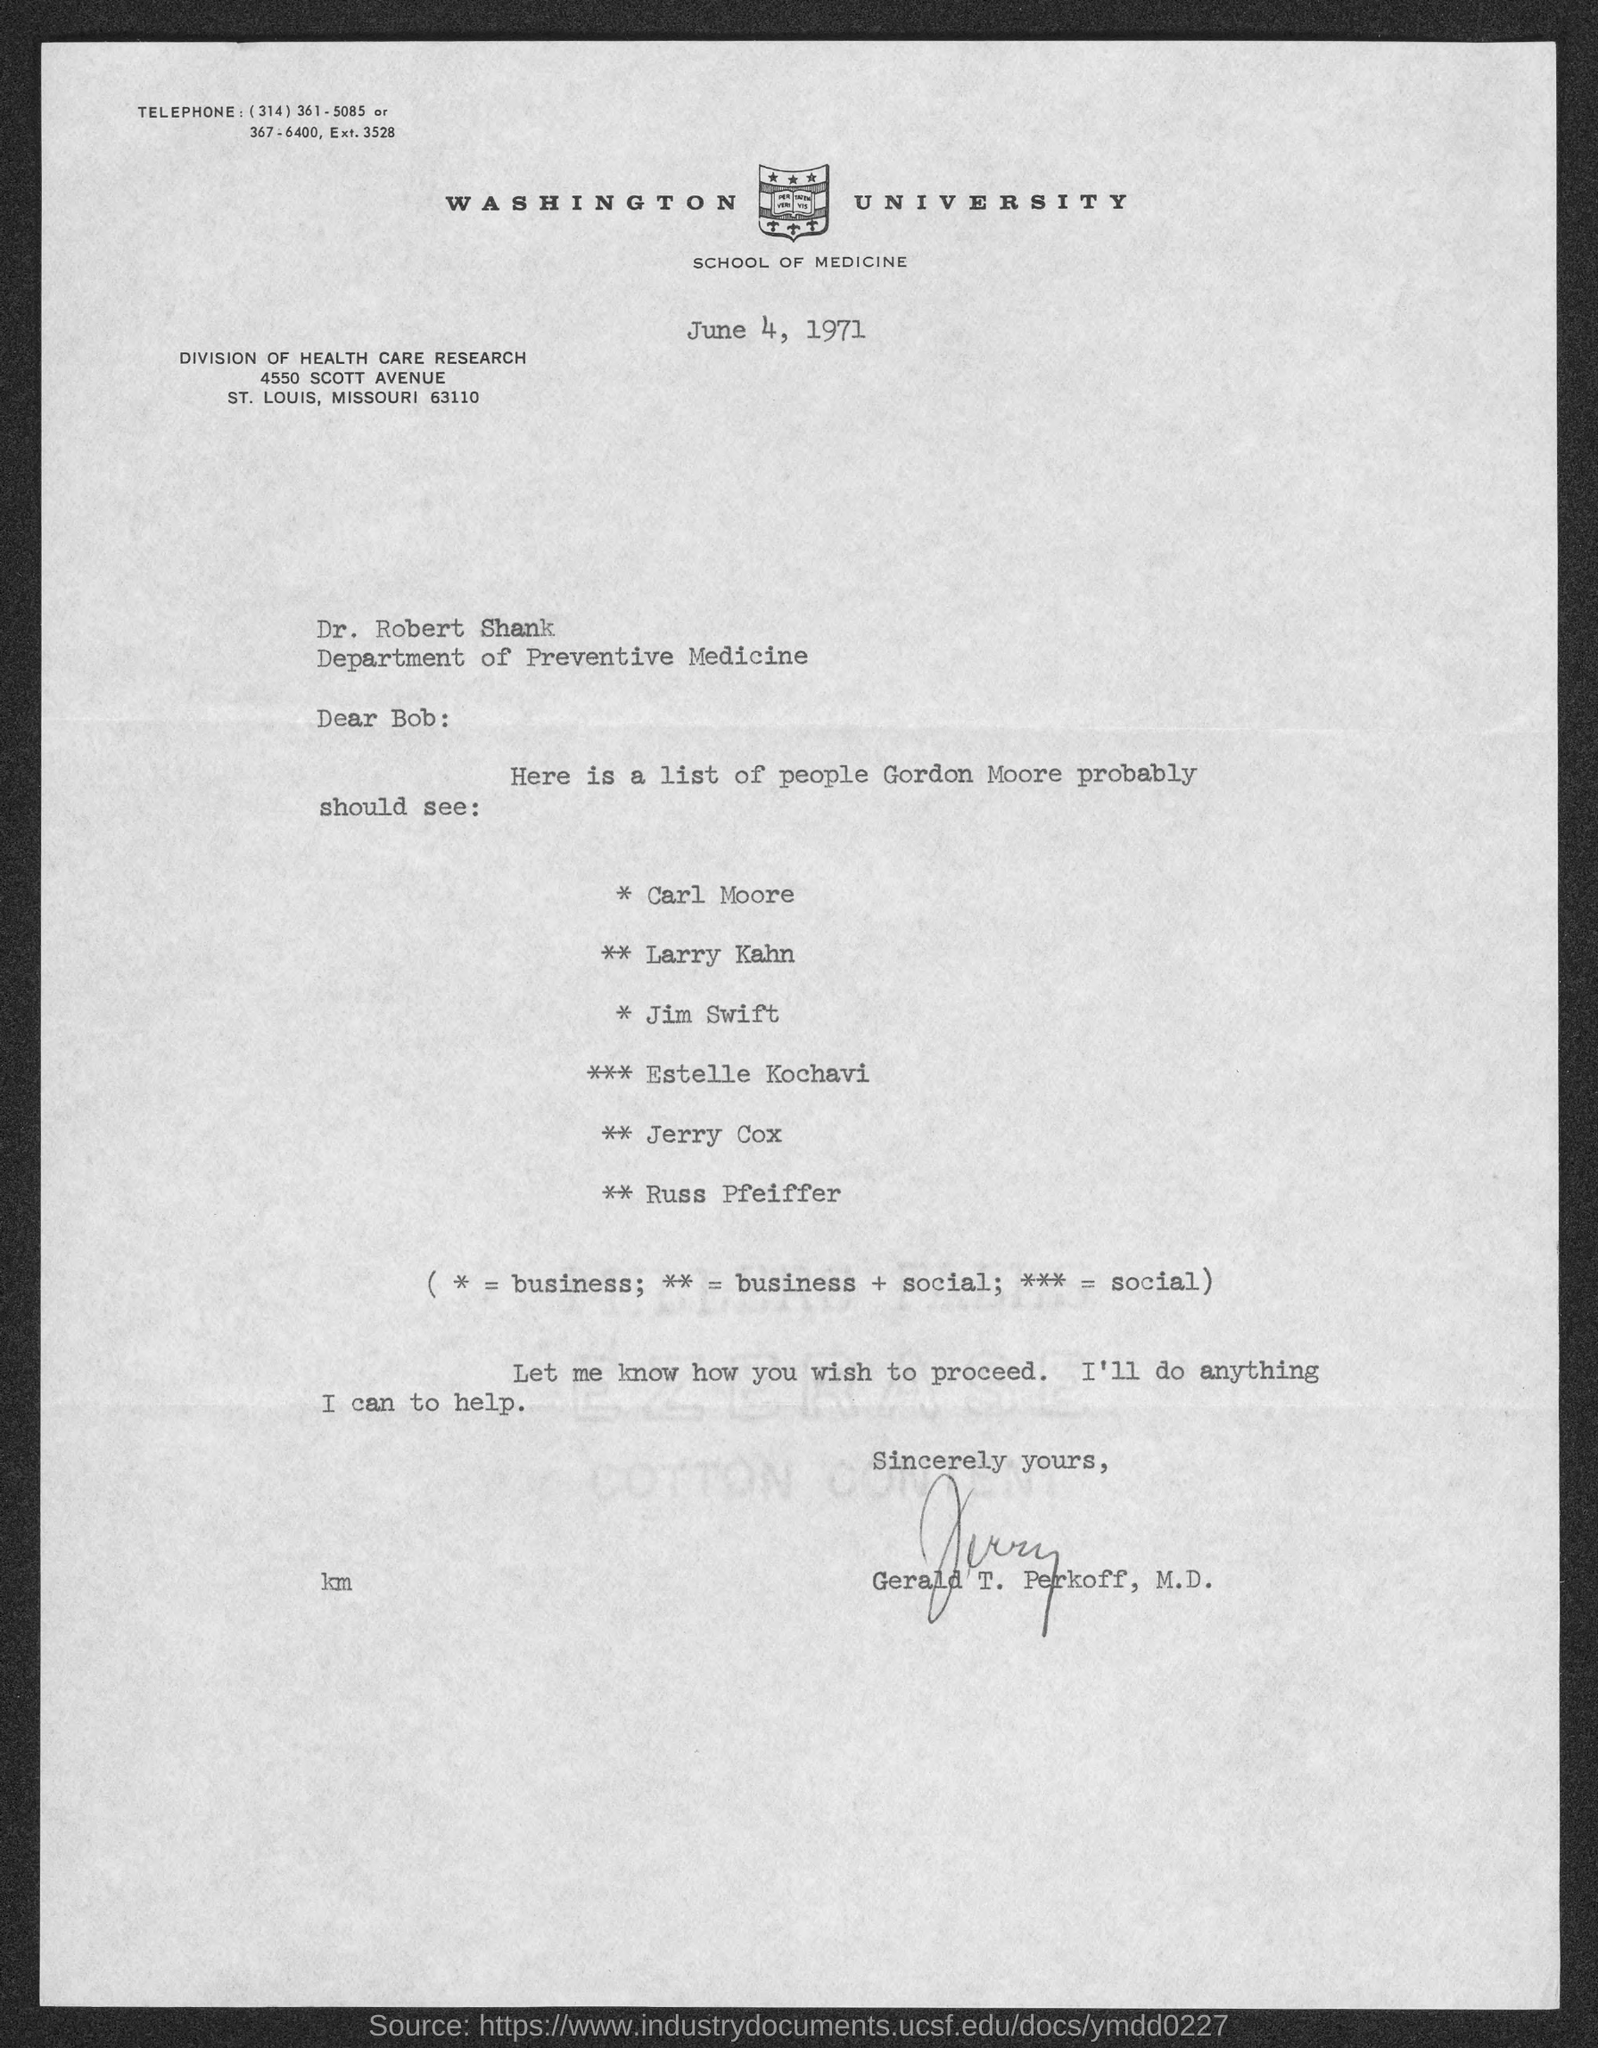When is the document dated?
Provide a succinct answer. June 4, 1971. To whom is the letter addressed?
Offer a very short reply. Bob. What does ** stand for?
Your answer should be very brief. Business + social. Whom should Gordon Moore see for social?
Make the answer very short. Estelle Kochavi. Who has signed the letter?
Your answer should be very brief. Gerald T. Perkoff. 